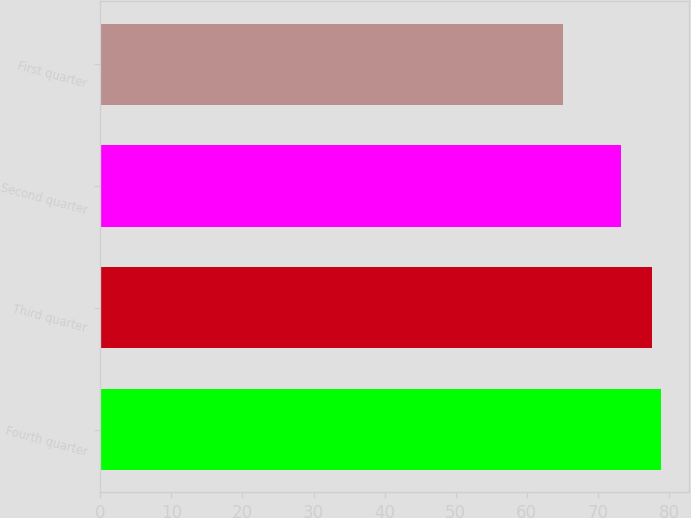Convert chart. <chart><loc_0><loc_0><loc_500><loc_500><bar_chart><fcel>Fourth quarter<fcel>Third quarter<fcel>Second quarter<fcel>First quarter<nl><fcel>78.89<fcel>77.55<fcel>73.3<fcel>65.13<nl></chart> 